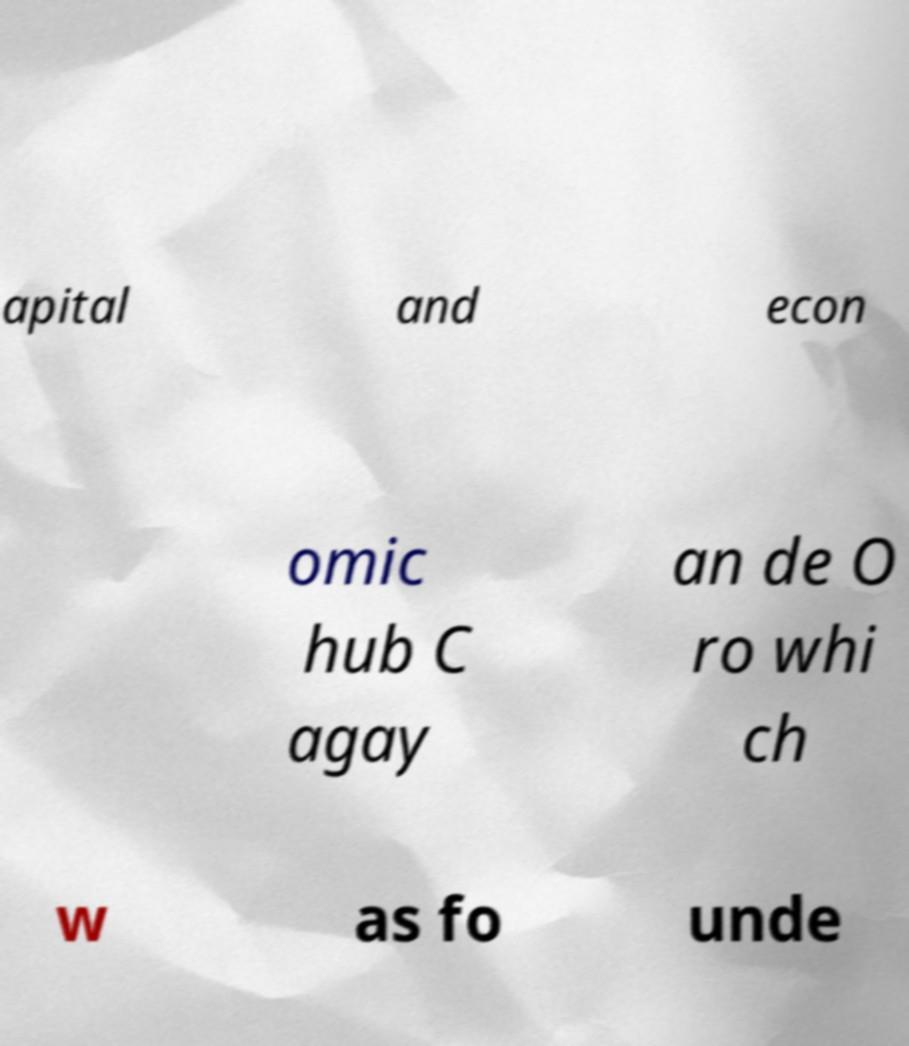Please read and relay the text visible in this image. What does it say? apital and econ omic hub C agay an de O ro whi ch w as fo unde 